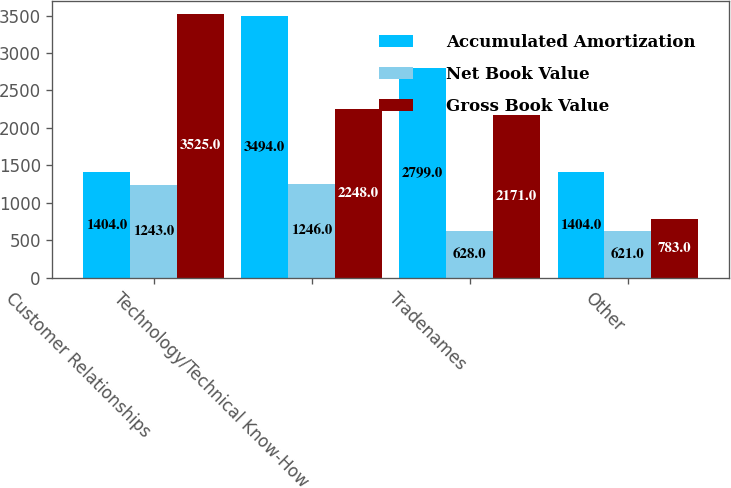Convert chart to OTSL. <chart><loc_0><loc_0><loc_500><loc_500><stacked_bar_chart><ecel><fcel>Customer Relationships<fcel>Technology/Technical Know-How<fcel>Tradenames<fcel>Other<nl><fcel>Accumulated Amortization<fcel>1404<fcel>3494<fcel>2799<fcel>1404<nl><fcel>Net Book Value<fcel>1243<fcel>1246<fcel>628<fcel>621<nl><fcel>Gross Book Value<fcel>3525<fcel>2248<fcel>2171<fcel>783<nl></chart> 